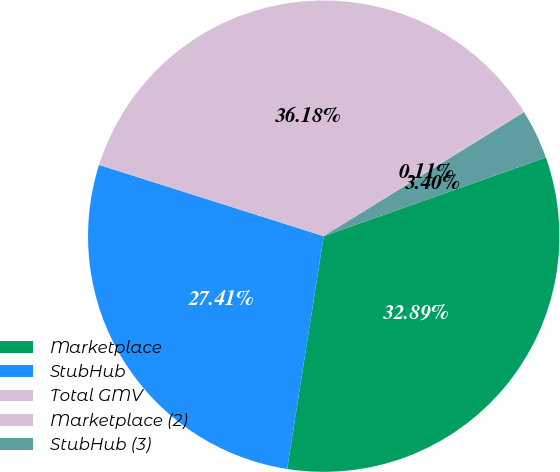<chart> <loc_0><loc_0><loc_500><loc_500><pie_chart><fcel>Marketplace<fcel>StubHub<fcel>Total GMV<fcel>Marketplace (2)<fcel>StubHub (3)<nl><fcel>32.89%<fcel>27.41%<fcel>36.18%<fcel>0.11%<fcel>3.4%<nl></chart> 